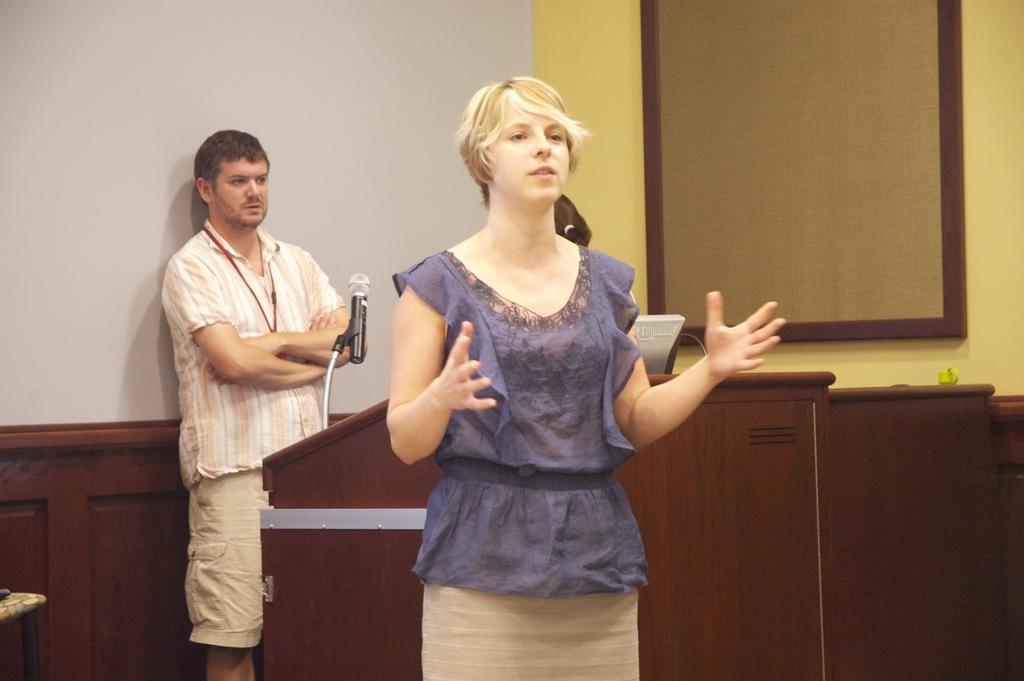Can you describe this image briefly? Here we can see two people. Podium with mic. This is white background. 